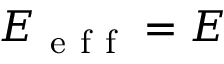<formula> <loc_0><loc_0><loc_500><loc_500>E _ { e f f } = E</formula> 